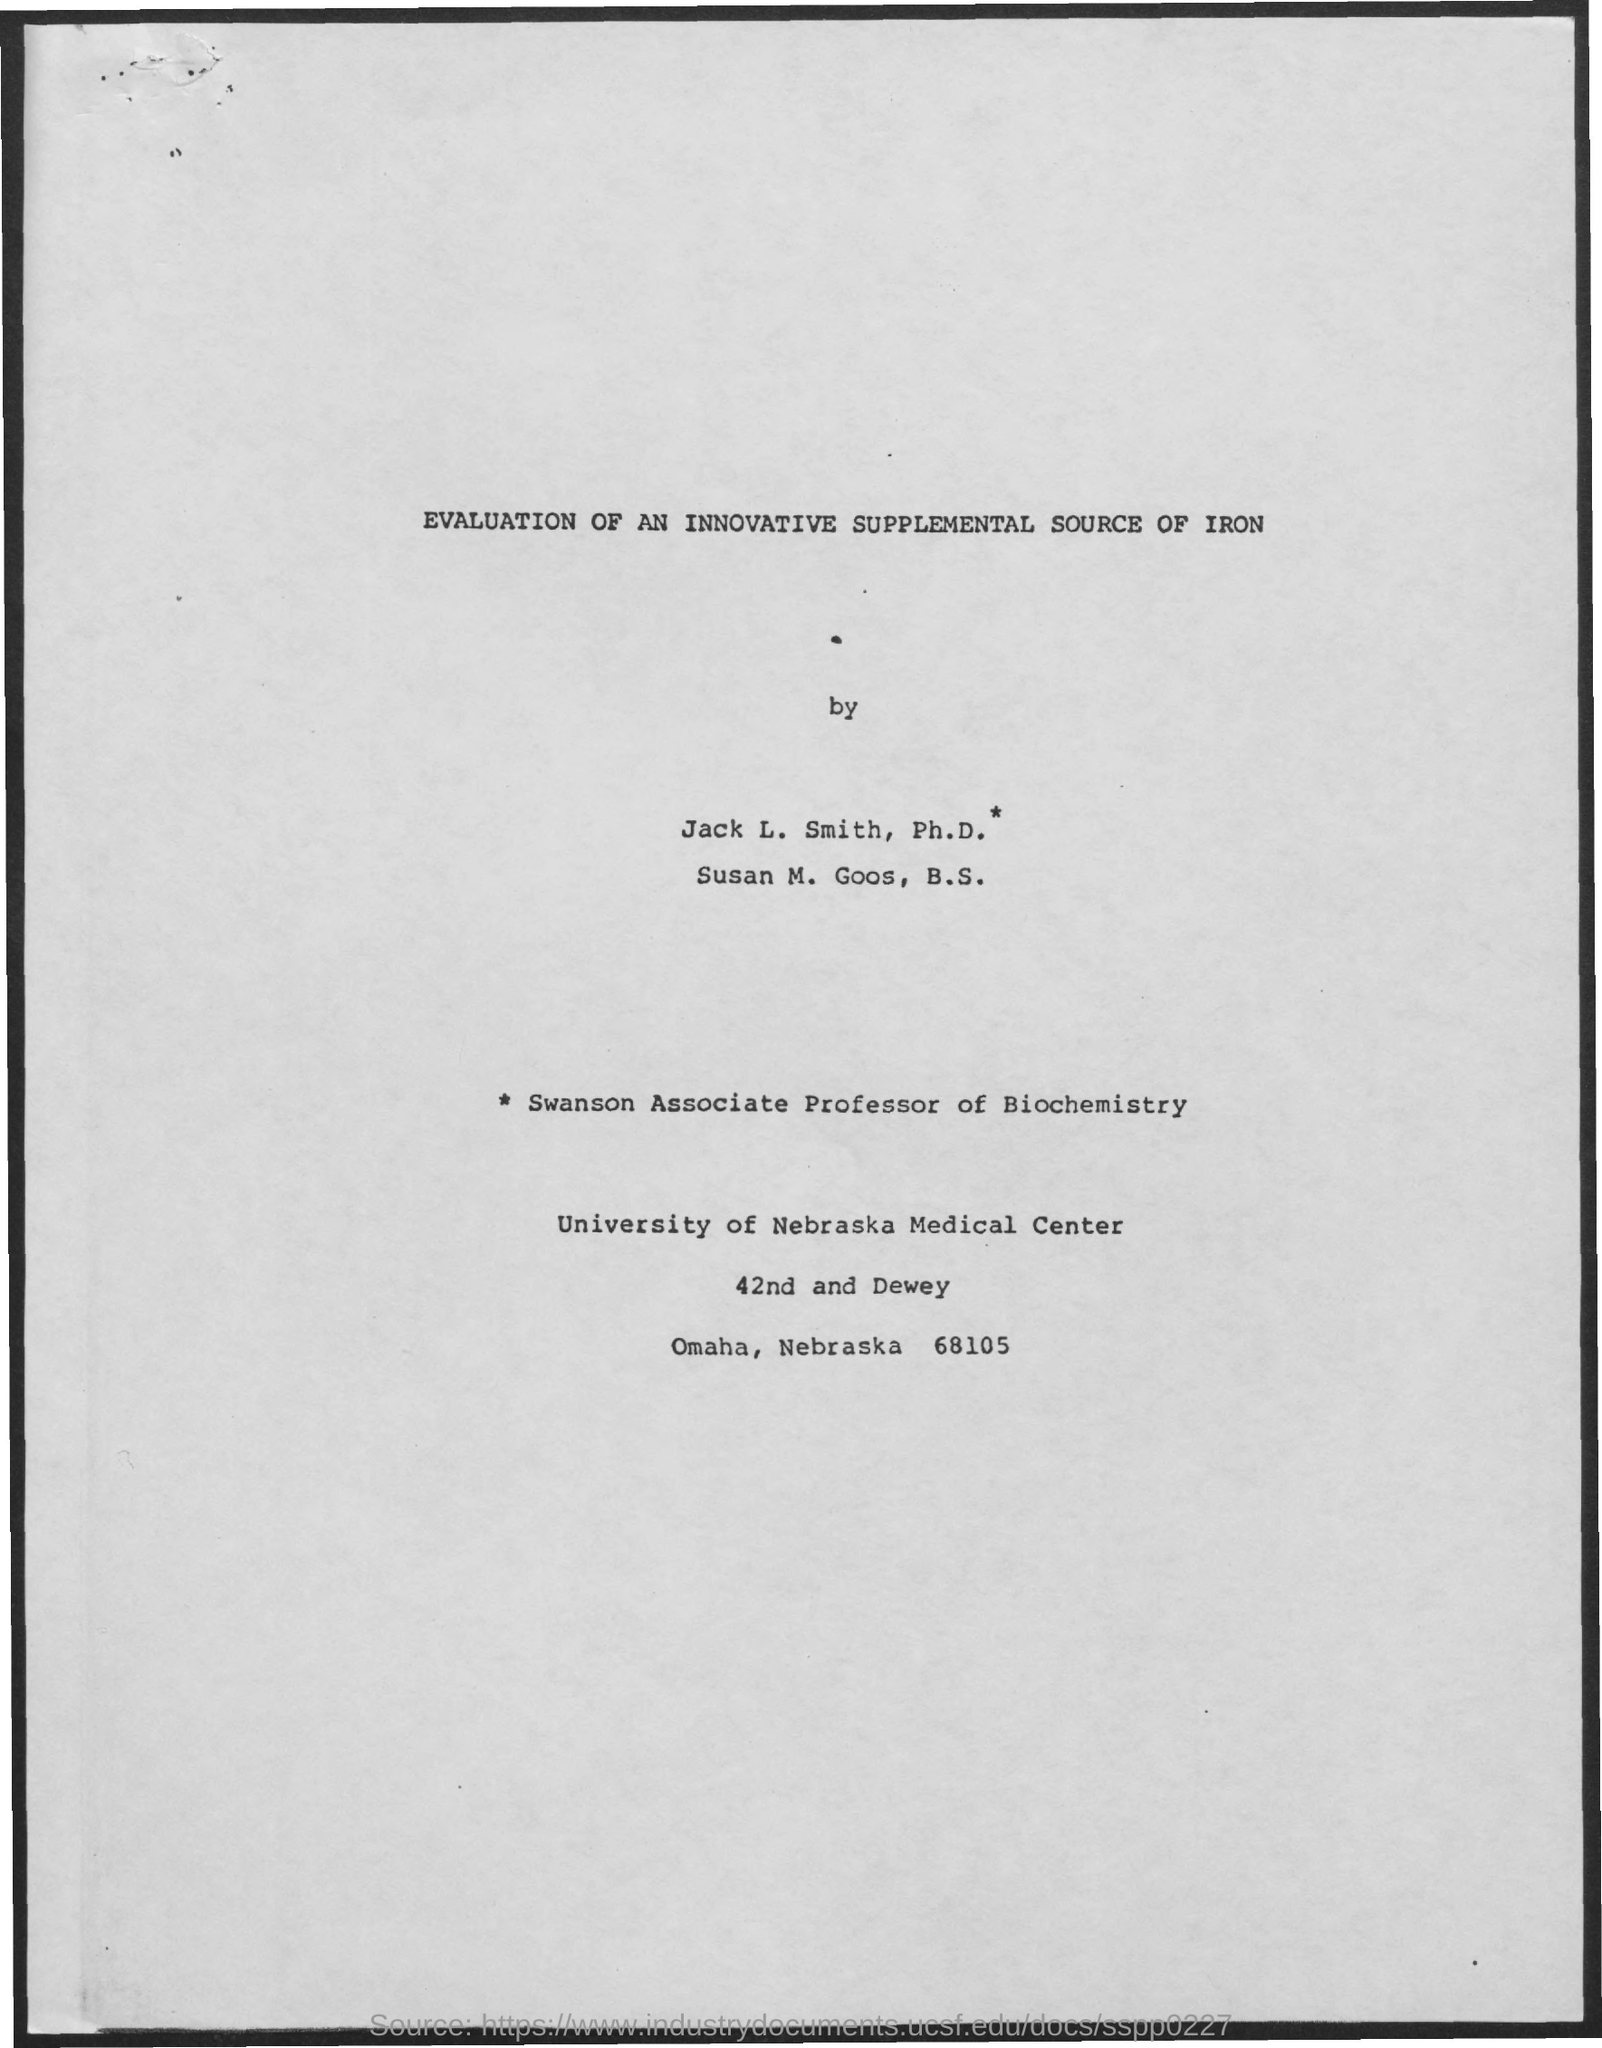Give some essential details in this illustration. The title of the document is 'Evaluation of an Innovative Supplemental Source of Iron,' which focuses on assessing the effectiveness and safety of a new supplement as a source of iron. 